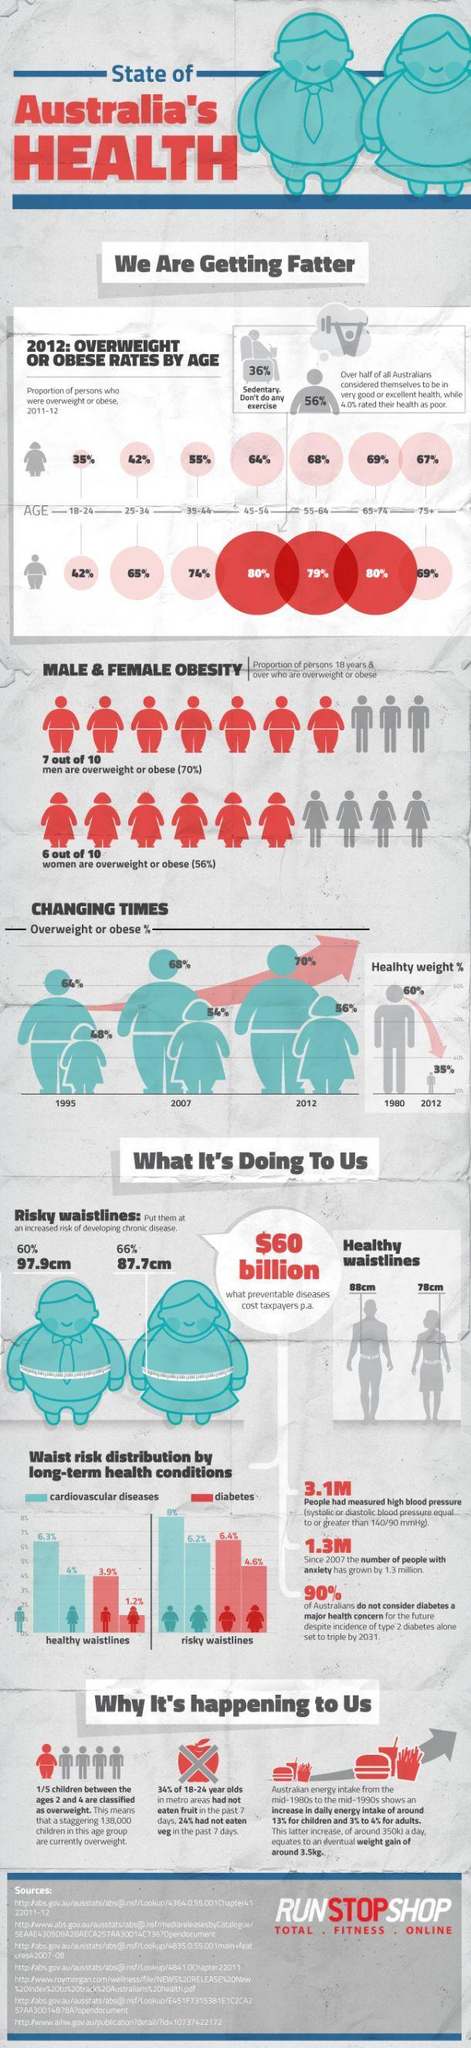Which year shows a total increase in Obese percentage of men and women as 126%?
Answer the question with a short phrase. 2012 What is the healthy waistline for men? 88 cm How many types of long term health condition can waist risk distribution produce? 2 What is the healthy waistline for women? 78 cm What is percentage difference in men with diabetes having  healthy waistlines and men with diabetes having risky waistline? 2.5% Which age group does the 36% of people with sedentary lifestyle belong? 45-54 Which age group of women were third highest  in obesity? 75+ What is total percentage of adults (18-24) who have not had fruits or vegetables in a week ? 58% Which gender does people with sedentary lifestyle belong? male What is the percentage obese rates in the age groups 45-54 and 65-74? 80% 